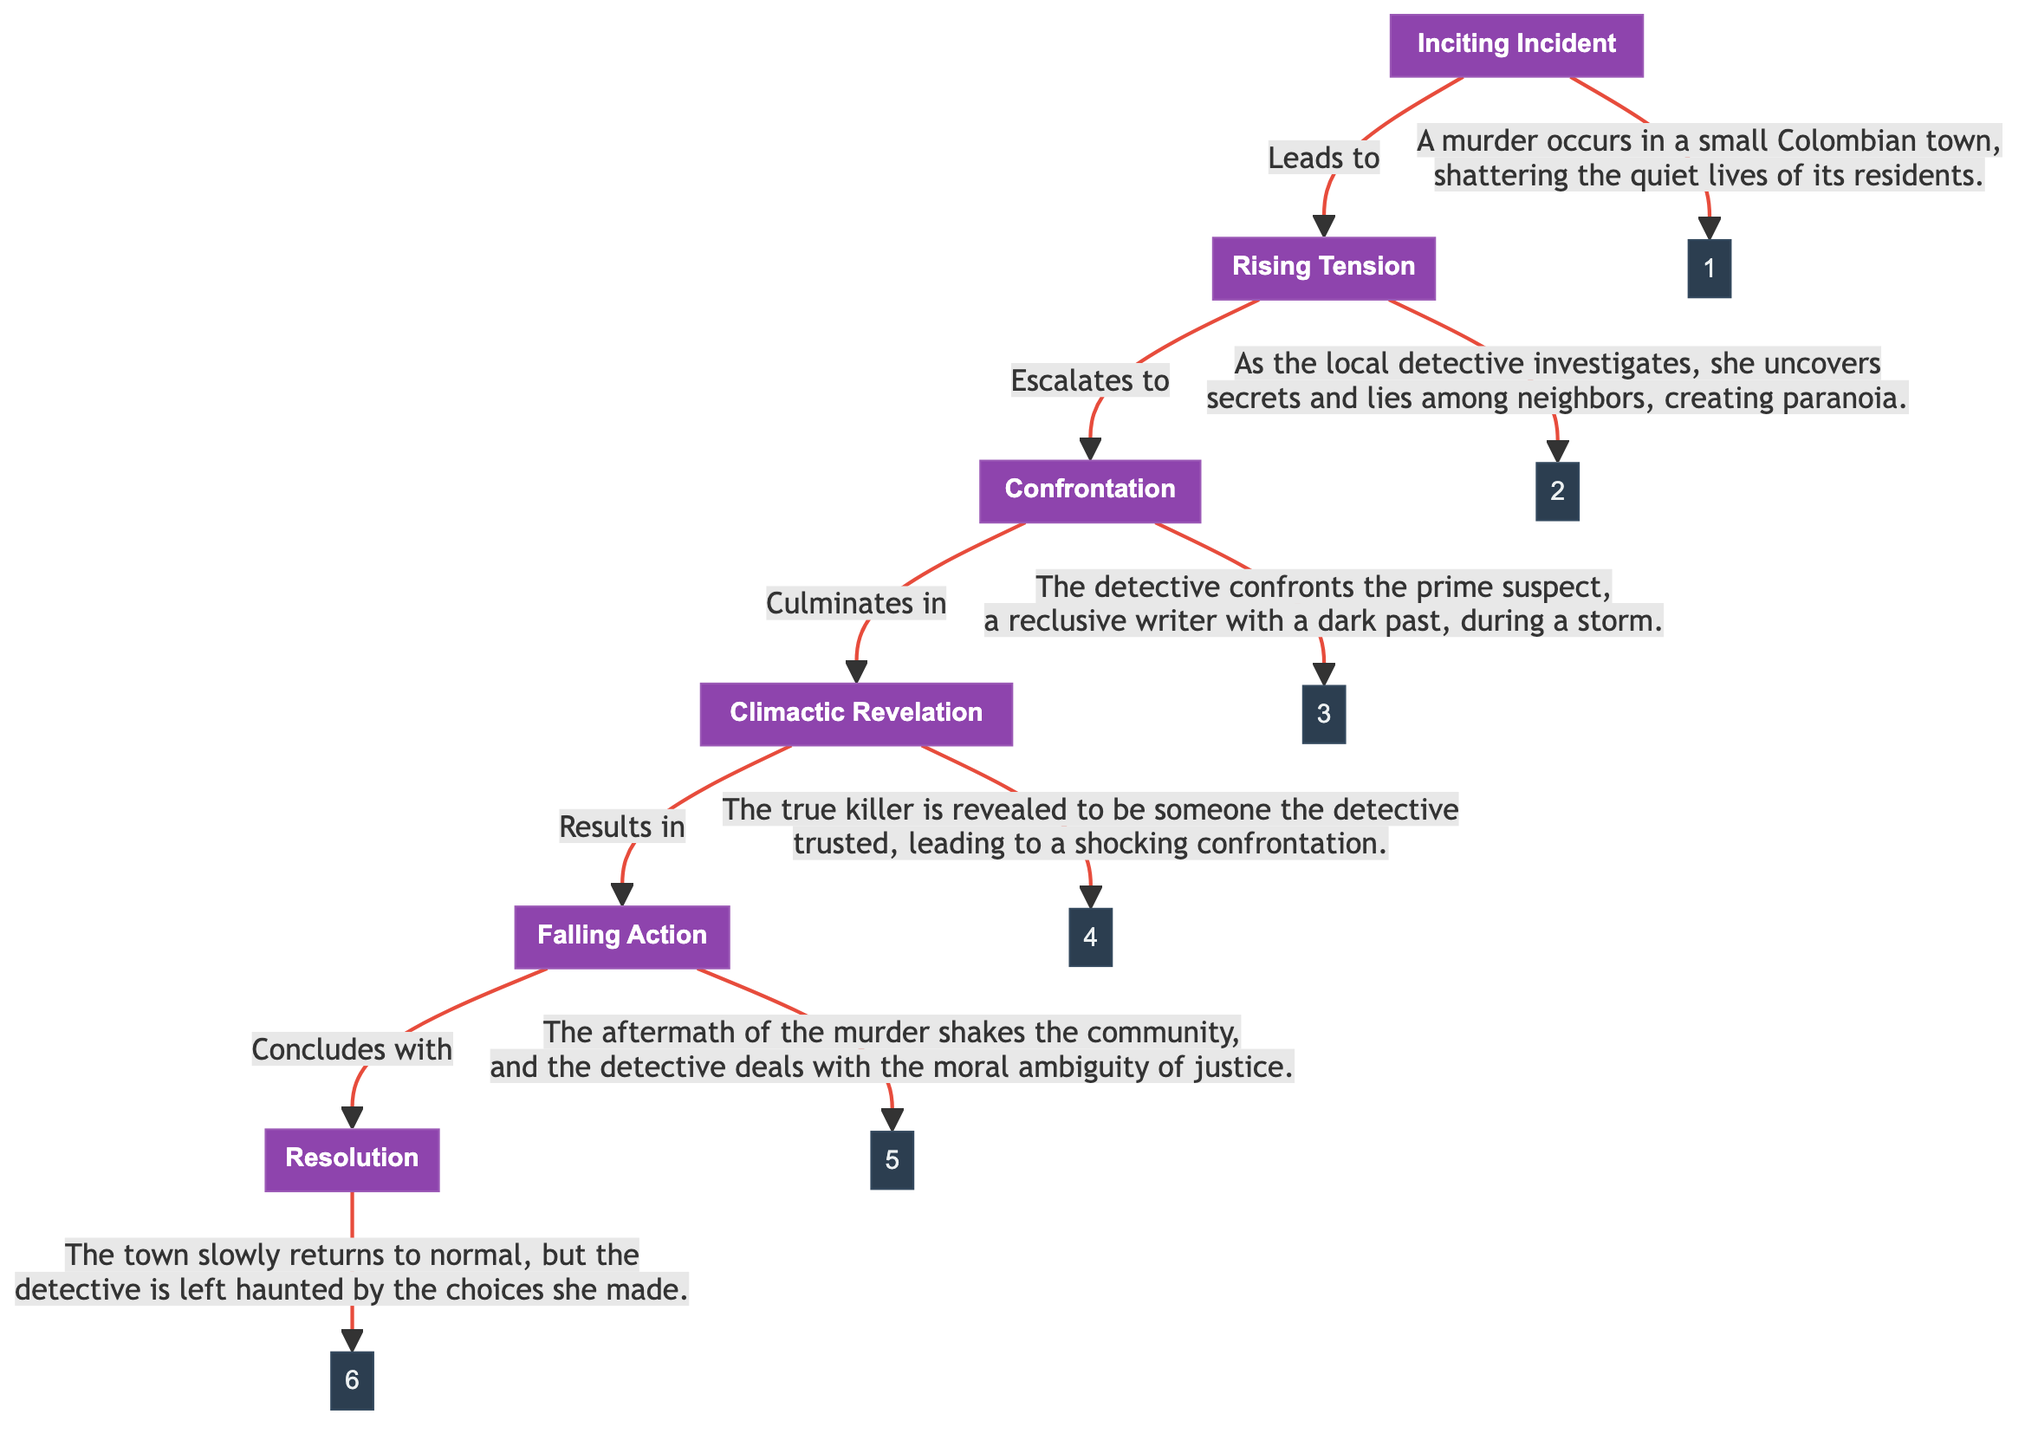What is the first stage in the plot structure flow? The first stage is "Inciting Incident," which is clearly labeled in the diagram.
Answer: Inciting Incident How many stages are there in the plot structure flow? Counting the nodes in the diagram, there are six stages: Inciting Incident, Rising Tension, Confrontation, Climactic Revelation, Falling Action, and Resolution.
Answer: 6 What leads to the Rising Tension stage? The transition from the Inciting Incident stage to the Rising Tension stage is indicated by the arrow labeled "Leads to," connecting the two stages.
Answer: Inciting Incident What is the main event that occurs during the Falling Action stage? The Falling Action stage describes the aftermath of the murder in the community, revealing that the detective grapples with moral ambiguity regarding justice.
Answer: Aftermath of the murder Who is the prime suspect confronted during the Confrontation stage? The description associated with the Confrontation stage states that the prime suspect is "a reclusive writer with a dark past."
Answer: A reclusive writer What is the outcome of the Climactic Revelation stage? The Climactic Revelation stage results in revealing the true killer, which is specified in the description connected to that stage.
Answer: A trusted person How does the plot resolve according to the Resolution stage? The Resolution stage indicates that the town slowly returns to normal, but it points out that the detective remains haunted by her choices, consolidating the resolution of both the community and the character.
Answer: Town returns to normal, detective haunted What does the Rising Tension stage escalate into? The Rising Tension stage escalates into the Confrontation stage, as indicated by the arrow labeled "Escalates to," demonstrating the progression of the plot.
Answer: Confrontation What theme is suggested by the overall flow of the plot structure? The overall plot structure flow suggests themes of murder, secrets, trust, and the moral dilemmas faced by individuals, common in dark suspense narratives.
Answer: Murder and moral ambiguity 